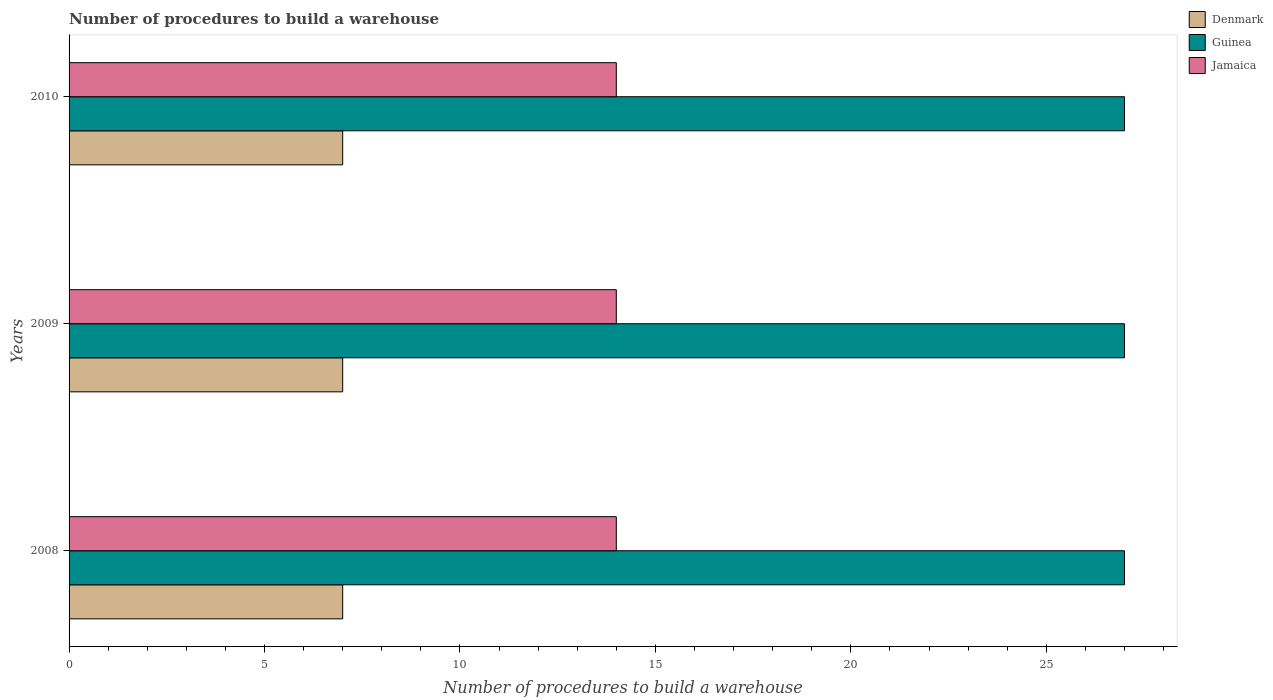How many different coloured bars are there?
Your answer should be compact. 3. How many groups of bars are there?
Your response must be concise. 3. Are the number of bars per tick equal to the number of legend labels?
Keep it short and to the point. Yes. How many bars are there on the 2nd tick from the bottom?
Provide a succinct answer. 3. What is the label of the 2nd group of bars from the top?
Give a very brief answer. 2009. In how many cases, is the number of bars for a given year not equal to the number of legend labels?
Your answer should be very brief. 0. What is the number of procedures to build a warehouse in in Guinea in 2009?
Offer a terse response. 27. Across all years, what is the maximum number of procedures to build a warehouse in in Denmark?
Your answer should be compact. 7. Across all years, what is the minimum number of procedures to build a warehouse in in Denmark?
Your answer should be very brief. 7. In which year was the number of procedures to build a warehouse in in Denmark maximum?
Your answer should be compact. 2008. What is the total number of procedures to build a warehouse in in Denmark in the graph?
Ensure brevity in your answer.  21. What is the difference between the number of procedures to build a warehouse in in Guinea in 2009 and the number of procedures to build a warehouse in in Jamaica in 2008?
Provide a short and direct response. 13. What is the average number of procedures to build a warehouse in in Guinea per year?
Give a very brief answer. 27. In the year 2010, what is the difference between the number of procedures to build a warehouse in in Guinea and number of procedures to build a warehouse in in Denmark?
Your answer should be very brief. 20. What is the ratio of the number of procedures to build a warehouse in in Denmark in 2009 to that in 2010?
Your answer should be compact. 1. What is the difference between the highest and the lowest number of procedures to build a warehouse in in Denmark?
Offer a terse response. 0. In how many years, is the number of procedures to build a warehouse in in Guinea greater than the average number of procedures to build a warehouse in in Guinea taken over all years?
Keep it short and to the point. 0. Is the sum of the number of procedures to build a warehouse in in Jamaica in 2008 and 2010 greater than the maximum number of procedures to build a warehouse in in Guinea across all years?
Provide a short and direct response. Yes. What does the 1st bar from the top in 2010 represents?
Give a very brief answer. Jamaica. What does the 2nd bar from the bottom in 2010 represents?
Offer a terse response. Guinea. Is it the case that in every year, the sum of the number of procedures to build a warehouse in in Guinea and number of procedures to build a warehouse in in Denmark is greater than the number of procedures to build a warehouse in in Jamaica?
Provide a short and direct response. Yes. What is the difference between two consecutive major ticks on the X-axis?
Provide a short and direct response. 5. Are the values on the major ticks of X-axis written in scientific E-notation?
Offer a terse response. No. Does the graph contain grids?
Provide a succinct answer. No. How are the legend labels stacked?
Provide a short and direct response. Vertical. What is the title of the graph?
Provide a succinct answer. Number of procedures to build a warehouse. Does "United Arab Emirates" appear as one of the legend labels in the graph?
Give a very brief answer. No. What is the label or title of the X-axis?
Your answer should be very brief. Number of procedures to build a warehouse. What is the Number of procedures to build a warehouse of Guinea in 2008?
Provide a short and direct response. 27. What is the Number of procedures to build a warehouse in Guinea in 2009?
Your answer should be compact. 27. What is the Number of procedures to build a warehouse in Guinea in 2010?
Your answer should be compact. 27. Across all years, what is the maximum Number of procedures to build a warehouse of Denmark?
Provide a short and direct response. 7. Across all years, what is the minimum Number of procedures to build a warehouse in Guinea?
Your response must be concise. 27. What is the total Number of procedures to build a warehouse of Denmark in the graph?
Offer a very short reply. 21. What is the difference between the Number of procedures to build a warehouse of Denmark in 2008 and that in 2009?
Ensure brevity in your answer.  0. What is the difference between the Number of procedures to build a warehouse in Guinea in 2008 and that in 2009?
Make the answer very short. 0. What is the difference between the Number of procedures to build a warehouse in Jamaica in 2008 and that in 2009?
Make the answer very short. 0. What is the difference between the Number of procedures to build a warehouse in Denmark in 2008 and that in 2010?
Ensure brevity in your answer.  0. What is the difference between the Number of procedures to build a warehouse in Denmark in 2009 and that in 2010?
Provide a short and direct response. 0. What is the difference between the Number of procedures to build a warehouse in Denmark in 2008 and the Number of procedures to build a warehouse in Guinea in 2009?
Your answer should be compact. -20. What is the difference between the Number of procedures to build a warehouse in Denmark in 2008 and the Number of procedures to build a warehouse in Jamaica in 2009?
Offer a very short reply. -7. What is the difference between the Number of procedures to build a warehouse of Denmark in 2008 and the Number of procedures to build a warehouse of Jamaica in 2010?
Ensure brevity in your answer.  -7. What is the difference between the Number of procedures to build a warehouse in Denmark in 2009 and the Number of procedures to build a warehouse in Guinea in 2010?
Keep it short and to the point. -20. What is the difference between the Number of procedures to build a warehouse of Denmark in 2009 and the Number of procedures to build a warehouse of Jamaica in 2010?
Offer a very short reply. -7. What is the difference between the Number of procedures to build a warehouse in Guinea in 2009 and the Number of procedures to build a warehouse in Jamaica in 2010?
Make the answer very short. 13. What is the average Number of procedures to build a warehouse of Guinea per year?
Offer a terse response. 27. In the year 2009, what is the difference between the Number of procedures to build a warehouse in Denmark and Number of procedures to build a warehouse in Jamaica?
Offer a very short reply. -7. What is the ratio of the Number of procedures to build a warehouse in Guinea in 2008 to that in 2009?
Keep it short and to the point. 1. What is the ratio of the Number of procedures to build a warehouse in Jamaica in 2008 to that in 2009?
Offer a very short reply. 1. What is the ratio of the Number of procedures to build a warehouse of Guinea in 2008 to that in 2010?
Provide a succinct answer. 1. What is the ratio of the Number of procedures to build a warehouse of Jamaica in 2008 to that in 2010?
Your answer should be compact. 1. What is the ratio of the Number of procedures to build a warehouse in Denmark in 2009 to that in 2010?
Keep it short and to the point. 1. What is the ratio of the Number of procedures to build a warehouse in Jamaica in 2009 to that in 2010?
Offer a very short reply. 1. What is the difference between the highest and the second highest Number of procedures to build a warehouse in Jamaica?
Offer a very short reply. 0. 